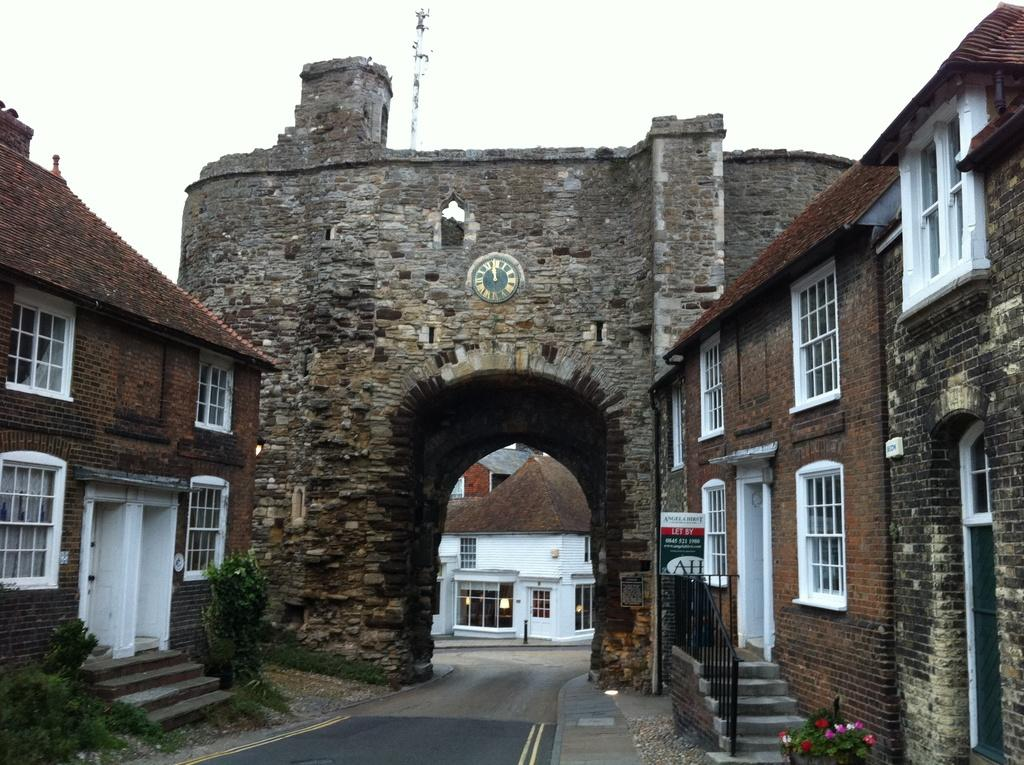What type of house is in the center of the image? There is a land house in the image. How many houses are near the land house? There are two houses near the land house. What decorative elements are present on either side of the land house? There are planets depicted on either side of the land house. Can you describe the house in the background of the image? There is another house in the background of the image. What type of guitar can be seen being played in the image? There is no guitar present in the image. Is there a volleyball game happening in the background of the image? There is no volleyball game or any reference to a volleyball in the image. 